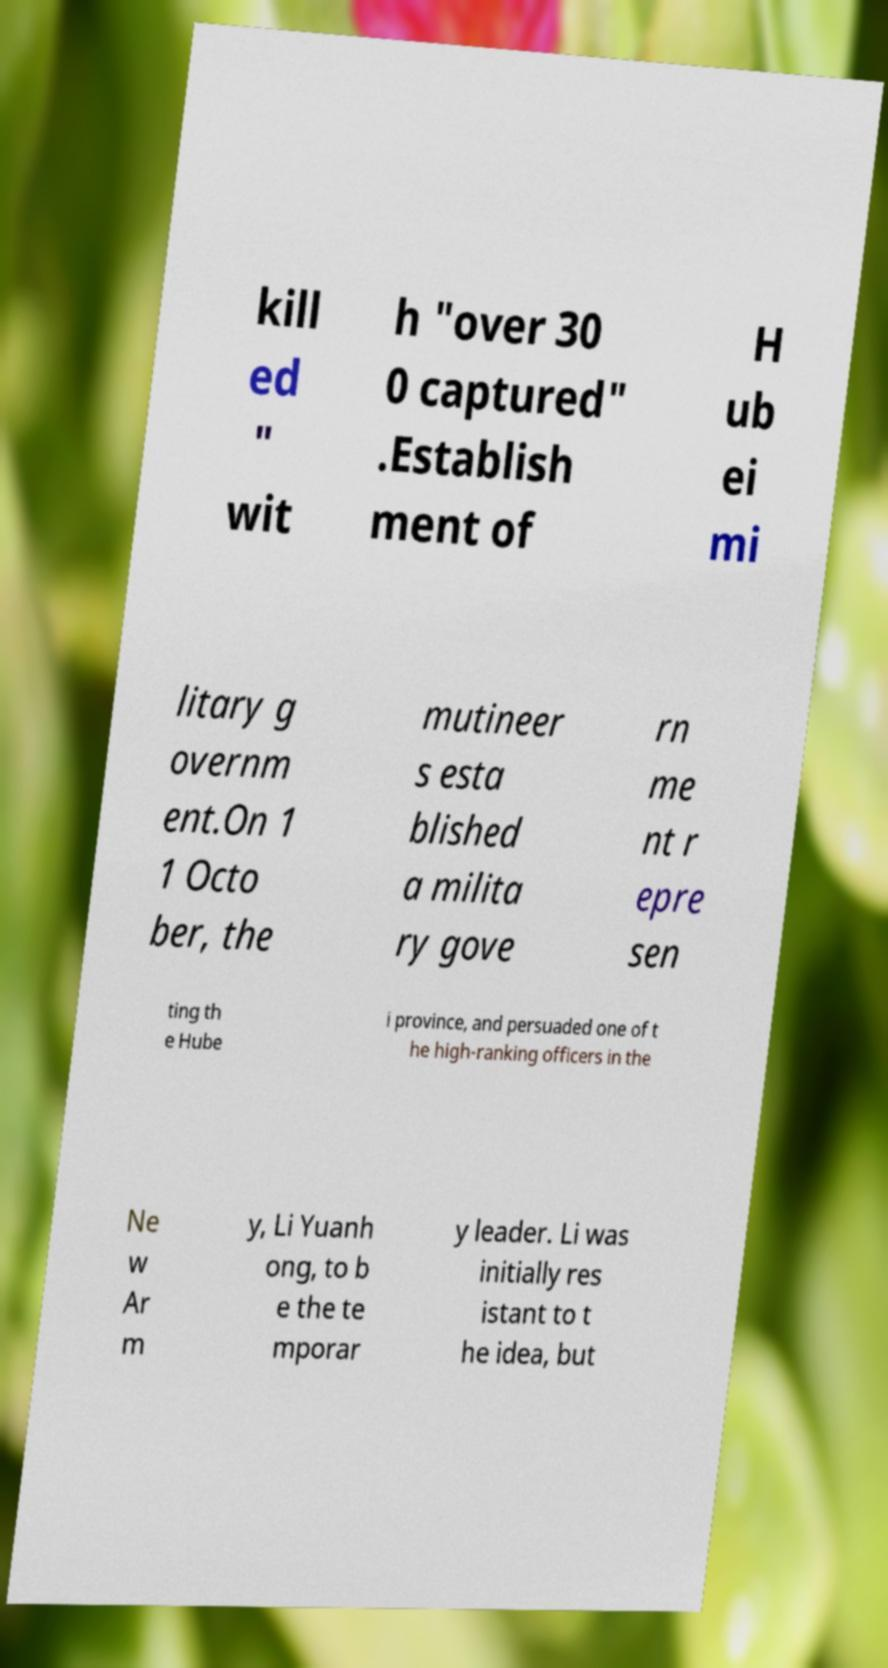I need the written content from this picture converted into text. Can you do that? kill ed " wit h "over 30 0 captured" .Establish ment of H ub ei mi litary g overnm ent.On 1 1 Octo ber, the mutineer s esta blished a milita ry gove rn me nt r epre sen ting th e Hube i province, and persuaded one of t he high-ranking officers in the Ne w Ar m y, Li Yuanh ong, to b e the te mporar y leader. Li was initially res istant to t he idea, but 